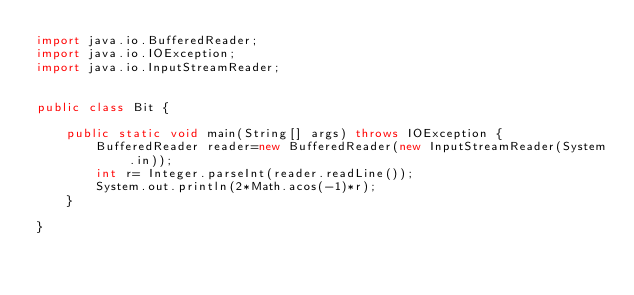Convert code to text. <code><loc_0><loc_0><loc_500><loc_500><_Java_>import java.io.BufferedReader;
import java.io.IOException;
import java.io.InputStreamReader;


public class Bit {

    public static void main(String[] args) throws IOException {
        BufferedReader reader=new BufferedReader(new InputStreamReader(System.in));
        int r= Integer.parseInt(reader.readLine());
        System.out.println(2*Math.acos(-1)*r);
    }

}
</code> 